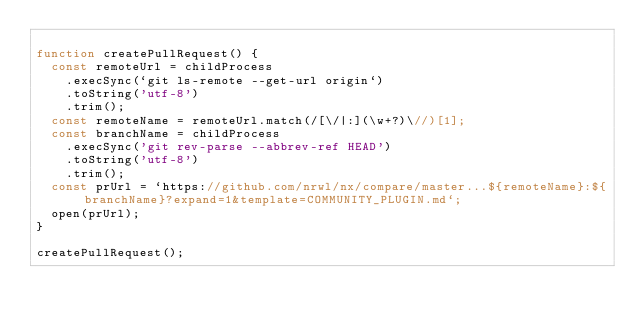Convert code to text. <code><loc_0><loc_0><loc_500><loc_500><_JavaScript_>
function createPullRequest() {
  const remoteUrl = childProcess
    .execSync(`git ls-remote --get-url origin`)
    .toString('utf-8')
    .trim();
  const remoteName = remoteUrl.match(/[\/|:](\w+?)\//)[1];
  const branchName = childProcess
    .execSync('git rev-parse --abbrev-ref HEAD')
    .toString('utf-8')
    .trim();
  const prUrl = `https://github.com/nrwl/nx/compare/master...${remoteName}:${branchName}?expand=1&template=COMMUNITY_PLUGIN.md`;
  open(prUrl);
}

createPullRequest();
</code> 